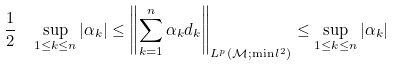Convert formula to latex. <formula><loc_0><loc_0><loc_500><loc_500>\frac { 1 } { 2 } \, \ \sup _ { 1 \leq k \leq n } | \alpha _ { k } | \leq \left \| \sum _ { k = 1 } ^ { n } \alpha _ { k } d _ { k } \right \| _ { L ^ { p } ( \mathcal { M } ; \min l ^ { 2 } ) } \leq \sup _ { 1 \leq k \leq n } | \alpha _ { k } |</formula> 